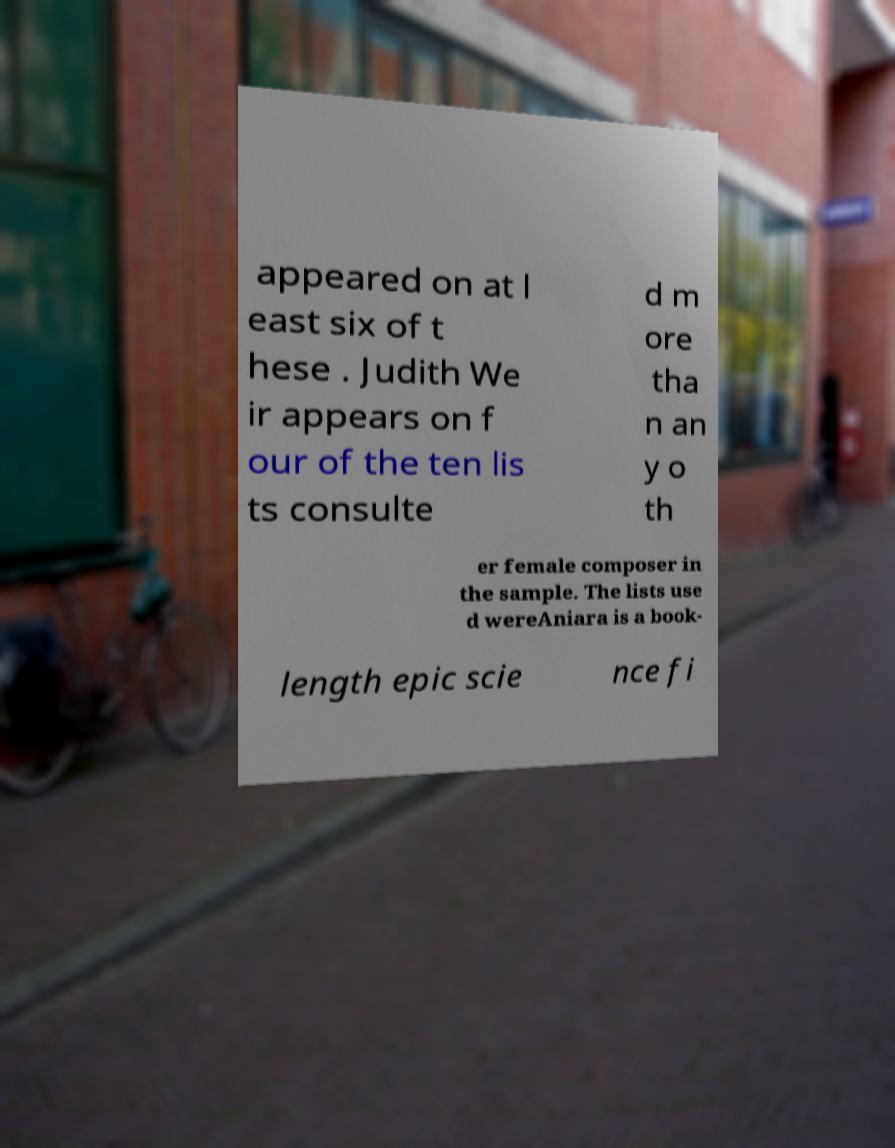Please read and relay the text visible in this image. What does it say? appeared on at l east six of t hese . Judith We ir appears on f our of the ten lis ts consulte d m ore tha n an y o th er female composer in the sample. The lists use d wereAniara is a book- length epic scie nce fi 